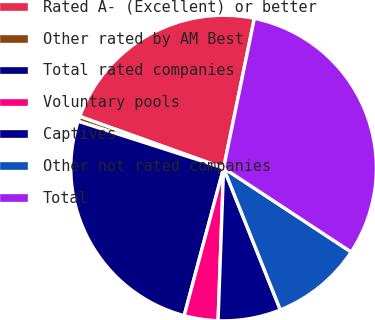<chart> <loc_0><loc_0><loc_500><loc_500><pie_chart><fcel>Rated A- (Excellent) or better<fcel>Other rated by AM Best<fcel>Total rated companies<fcel>Voluntary pools<fcel>Captives<fcel>Other not rated companies<fcel>Total<nl><fcel>22.75%<fcel>0.53%<fcel>25.8%<fcel>3.58%<fcel>6.63%<fcel>9.68%<fcel>31.04%<nl></chart> 